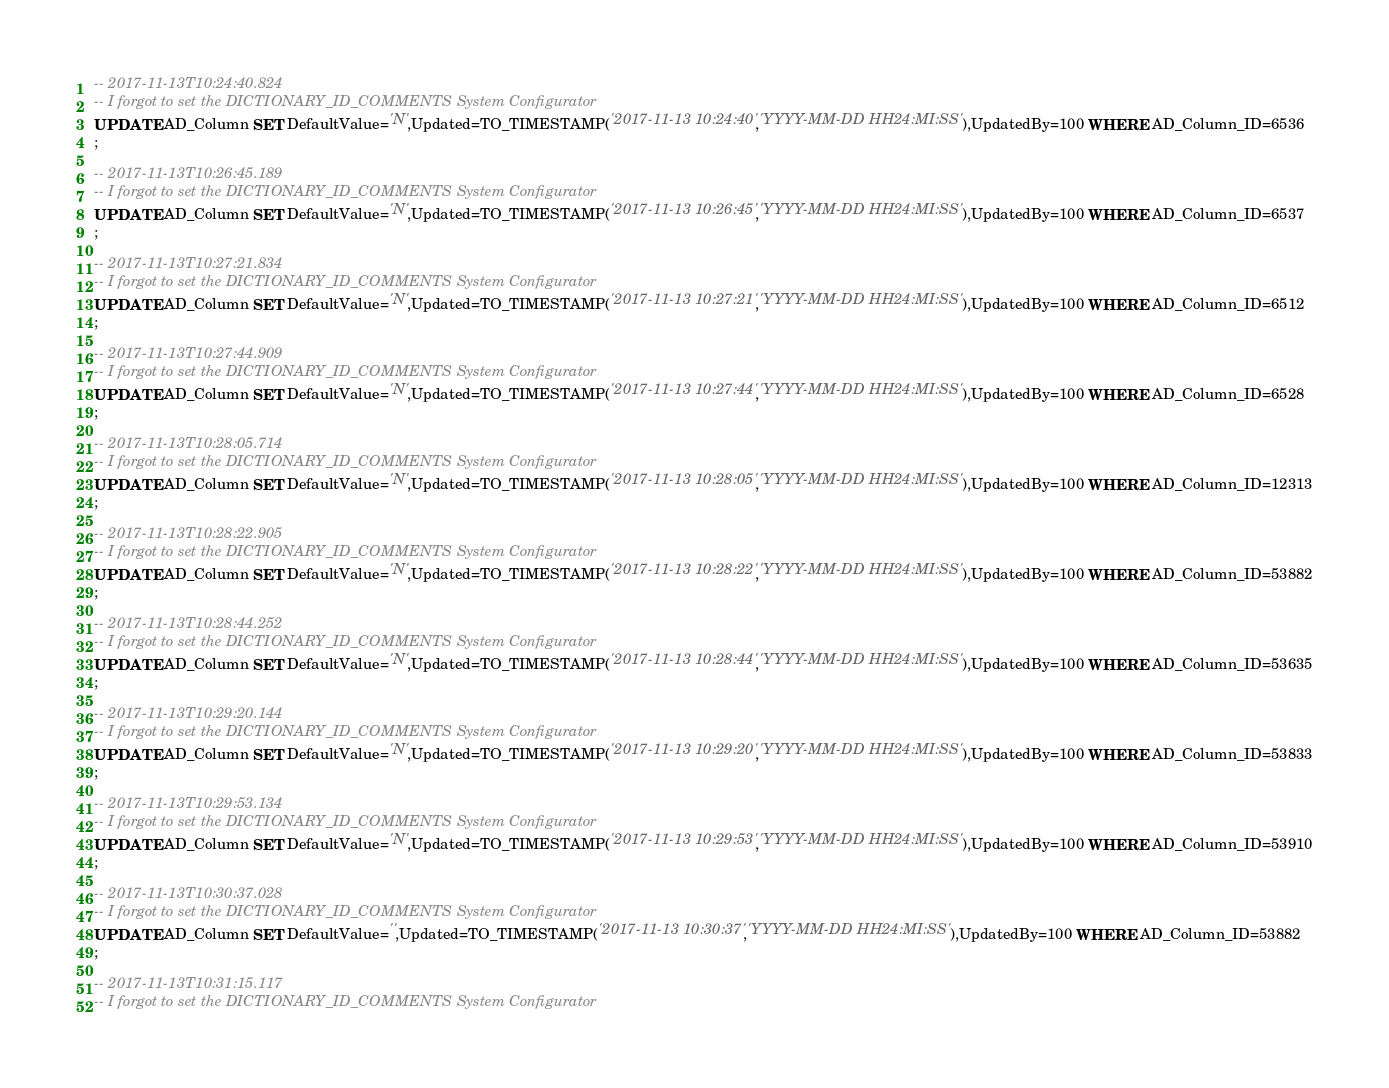Convert code to text. <code><loc_0><loc_0><loc_500><loc_500><_SQL_>-- 2017-11-13T10:24:40.824
-- I forgot to set the DICTIONARY_ID_COMMENTS System Configurator
UPDATE AD_Column SET DefaultValue='N',Updated=TO_TIMESTAMP('2017-11-13 10:24:40','YYYY-MM-DD HH24:MI:SS'),UpdatedBy=100 WHERE AD_Column_ID=6536
;

-- 2017-11-13T10:26:45.189
-- I forgot to set the DICTIONARY_ID_COMMENTS System Configurator
UPDATE AD_Column SET DefaultValue='N',Updated=TO_TIMESTAMP('2017-11-13 10:26:45','YYYY-MM-DD HH24:MI:SS'),UpdatedBy=100 WHERE AD_Column_ID=6537
;

-- 2017-11-13T10:27:21.834
-- I forgot to set the DICTIONARY_ID_COMMENTS System Configurator
UPDATE AD_Column SET DefaultValue='N',Updated=TO_TIMESTAMP('2017-11-13 10:27:21','YYYY-MM-DD HH24:MI:SS'),UpdatedBy=100 WHERE AD_Column_ID=6512
;

-- 2017-11-13T10:27:44.909
-- I forgot to set the DICTIONARY_ID_COMMENTS System Configurator
UPDATE AD_Column SET DefaultValue='N',Updated=TO_TIMESTAMP('2017-11-13 10:27:44','YYYY-MM-DD HH24:MI:SS'),UpdatedBy=100 WHERE AD_Column_ID=6528
;

-- 2017-11-13T10:28:05.714
-- I forgot to set the DICTIONARY_ID_COMMENTS System Configurator
UPDATE AD_Column SET DefaultValue='N',Updated=TO_TIMESTAMP('2017-11-13 10:28:05','YYYY-MM-DD HH24:MI:SS'),UpdatedBy=100 WHERE AD_Column_ID=12313
;

-- 2017-11-13T10:28:22.905
-- I forgot to set the DICTIONARY_ID_COMMENTS System Configurator
UPDATE AD_Column SET DefaultValue='N',Updated=TO_TIMESTAMP('2017-11-13 10:28:22','YYYY-MM-DD HH24:MI:SS'),UpdatedBy=100 WHERE AD_Column_ID=53882
;

-- 2017-11-13T10:28:44.252
-- I forgot to set the DICTIONARY_ID_COMMENTS System Configurator
UPDATE AD_Column SET DefaultValue='N',Updated=TO_TIMESTAMP('2017-11-13 10:28:44','YYYY-MM-DD HH24:MI:SS'),UpdatedBy=100 WHERE AD_Column_ID=53635
;

-- 2017-11-13T10:29:20.144
-- I forgot to set the DICTIONARY_ID_COMMENTS System Configurator
UPDATE AD_Column SET DefaultValue='N',Updated=TO_TIMESTAMP('2017-11-13 10:29:20','YYYY-MM-DD HH24:MI:SS'),UpdatedBy=100 WHERE AD_Column_ID=53833
;

-- 2017-11-13T10:29:53.134
-- I forgot to set the DICTIONARY_ID_COMMENTS System Configurator
UPDATE AD_Column SET DefaultValue='N',Updated=TO_TIMESTAMP('2017-11-13 10:29:53','YYYY-MM-DD HH24:MI:SS'),UpdatedBy=100 WHERE AD_Column_ID=53910
;

-- 2017-11-13T10:30:37.028
-- I forgot to set the DICTIONARY_ID_COMMENTS System Configurator
UPDATE AD_Column SET DefaultValue='',Updated=TO_TIMESTAMP('2017-11-13 10:30:37','YYYY-MM-DD HH24:MI:SS'),UpdatedBy=100 WHERE AD_Column_ID=53882
;

-- 2017-11-13T10:31:15.117
-- I forgot to set the DICTIONARY_ID_COMMENTS System Configurator</code> 